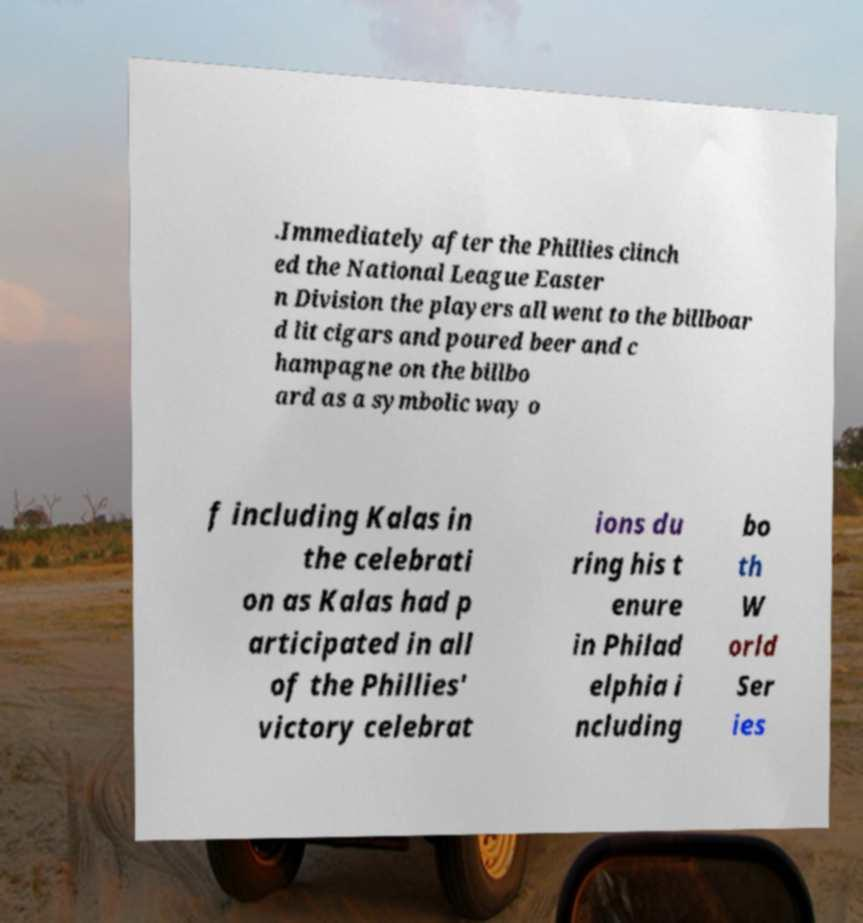Could you extract and type out the text from this image? .Immediately after the Phillies clinch ed the National League Easter n Division the players all went to the billboar d lit cigars and poured beer and c hampagne on the billbo ard as a symbolic way o f including Kalas in the celebrati on as Kalas had p articipated in all of the Phillies' victory celebrat ions du ring his t enure in Philad elphia i ncluding bo th W orld Ser ies 